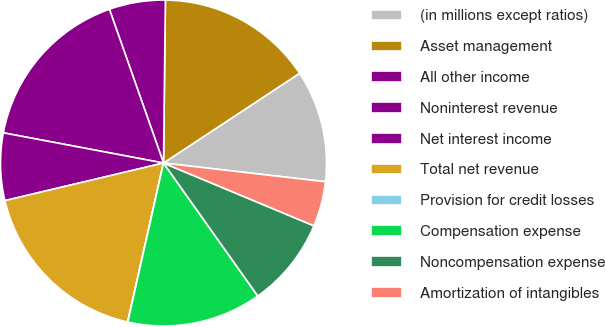<chart> <loc_0><loc_0><loc_500><loc_500><pie_chart><fcel>(in millions except ratios)<fcel>Asset management<fcel>All other income<fcel>Noninterest revenue<fcel>Net interest income<fcel>Total net revenue<fcel>Provision for credit losses<fcel>Compensation expense<fcel>Noncompensation expense<fcel>Amortization of intangibles<nl><fcel>11.11%<fcel>15.54%<fcel>5.57%<fcel>16.65%<fcel>6.67%<fcel>17.76%<fcel>0.02%<fcel>13.33%<fcel>8.89%<fcel>4.46%<nl></chart> 